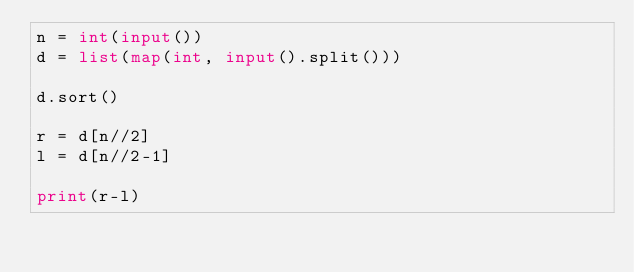Convert code to text. <code><loc_0><loc_0><loc_500><loc_500><_Python_>n = int(input())
d = list(map(int, input().split()))

d.sort()

r = d[n//2]
l = d[n//2-1]

print(r-l)</code> 